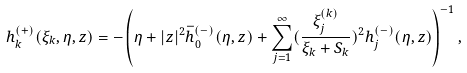<formula> <loc_0><loc_0><loc_500><loc_500>h _ { k } ^ { ( + ) } ( \xi _ { k } , \eta , z ) = - \left ( \eta + | z | ^ { 2 } \bar { h } _ { 0 } ^ { ( - ) } ( \eta , z ) + \sum _ { j = 1 } ^ { \infty } ( \frac { \xi ^ { ( k ) } _ { j } } { \xi _ { k } + S _ { k } } ) ^ { 2 } h _ { j } ^ { ( - ) } ( \eta , z ) \right ) ^ { - 1 } ,</formula> 